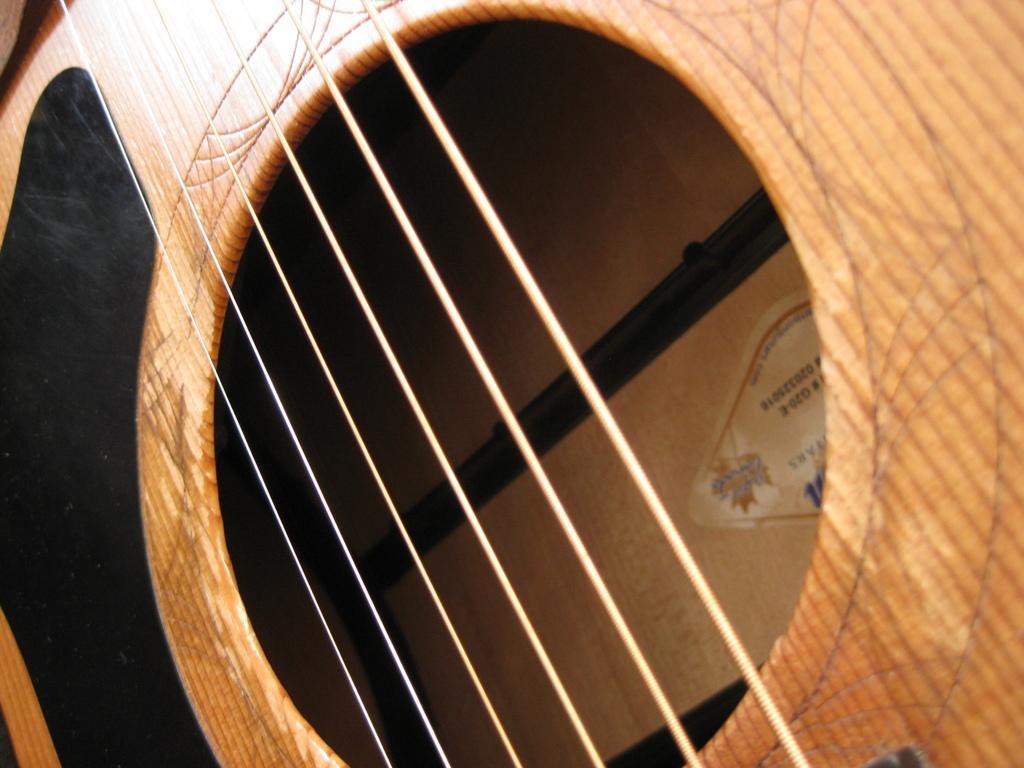Describe this image in one or two sentences. In this image it could be guitar and the guitar color is black and brown. 